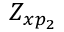Convert formula to latex. <formula><loc_0><loc_0><loc_500><loc_500>Z _ { x p _ { 2 } }</formula> 